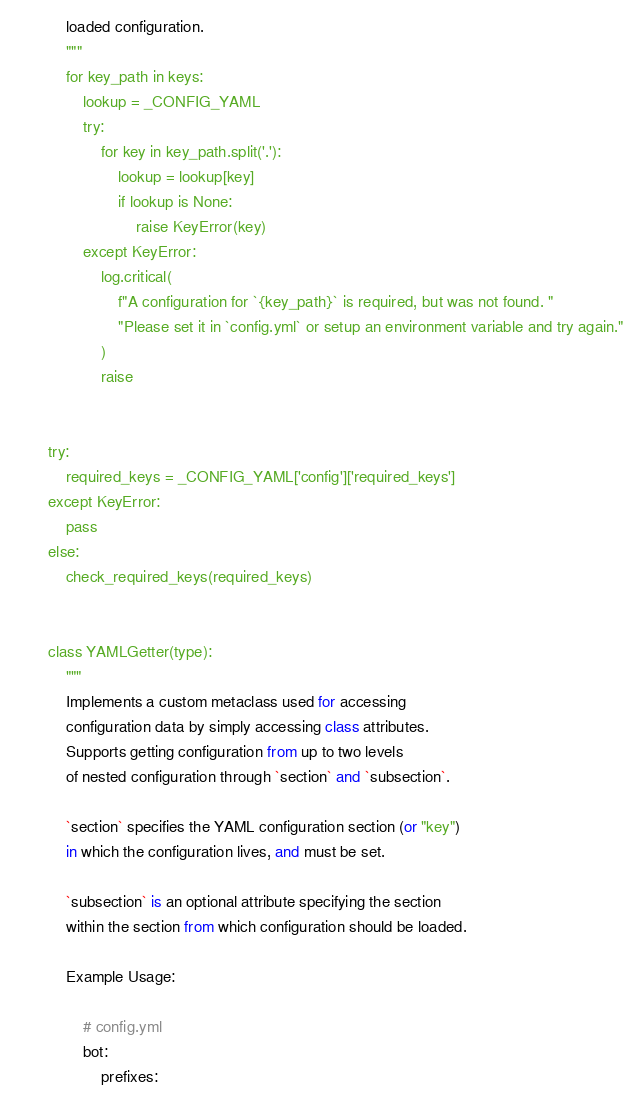Convert code to text. <code><loc_0><loc_0><loc_500><loc_500><_Python_>    loaded configuration.
    """
    for key_path in keys:
        lookup = _CONFIG_YAML
        try:
            for key in key_path.split('.'):
                lookup = lookup[key]
                if lookup is None:
                    raise KeyError(key)
        except KeyError:
            log.critical(
                f"A configuration for `{key_path}` is required, but was not found. "
                "Please set it in `config.yml` or setup an environment variable and try again."
            )
            raise


try:
    required_keys = _CONFIG_YAML['config']['required_keys']
except KeyError:
    pass
else:
    check_required_keys(required_keys)


class YAMLGetter(type):
    """
    Implements a custom metaclass used for accessing
    configuration data by simply accessing class attributes.
    Supports getting configuration from up to two levels
    of nested configuration through `section` and `subsection`.

    `section` specifies the YAML configuration section (or "key")
    in which the configuration lives, and must be set.

    `subsection` is an optional attribute specifying the section
    within the section from which configuration should be loaded.

    Example Usage:

        # config.yml
        bot:
            prefixes:</code> 